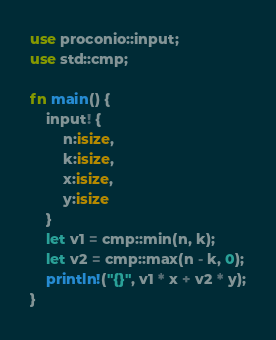<code> <loc_0><loc_0><loc_500><loc_500><_Rust_>use proconio::input;
use std::cmp;

fn main() {
    input! {
        n:isize,
        k:isize,
        x:isize,
        y:isize
    }
    let v1 = cmp::min(n, k);
    let v2 = cmp::max(n - k, 0);
    println!("{}", v1 * x + v2 * y);
}
</code> 